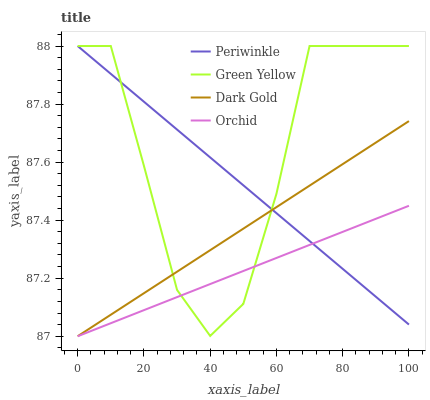Does Orchid have the minimum area under the curve?
Answer yes or no. Yes. Does Green Yellow have the maximum area under the curve?
Answer yes or no. Yes. Does Periwinkle have the minimum area under the curve?
Answer yes or no. No. Does Periwinkle have the maximum area under the curve?
Answer yes or no. No. Is Dark Gold the smoothest?
Answer yes or no. Yes. Is Green Yellow the roughest?
Answer yes or no. Yes. Is Periwinkle the smoothest?
Answer yes or no. No. Is Periwinkle the roughest?
Answer yes or no. No. Does Orchid have the lowest value?
Answer yes or no. Yes. Does Green Yellow have the lowest value?
Answer yes or no. No. Does Periwinkle have the highest value?
Answer yes or no. Yes. Does Dark Gold have the highest value?
Answer yes or no. No. Does Periwinkle intersect Green Yellow?
Answer yes or no. Yes. Is Periwinkle less than Green Yellow?
Answer yes or no. No. Is Periwinkle greater than Green Yellow?
Answer yes or no. No. 